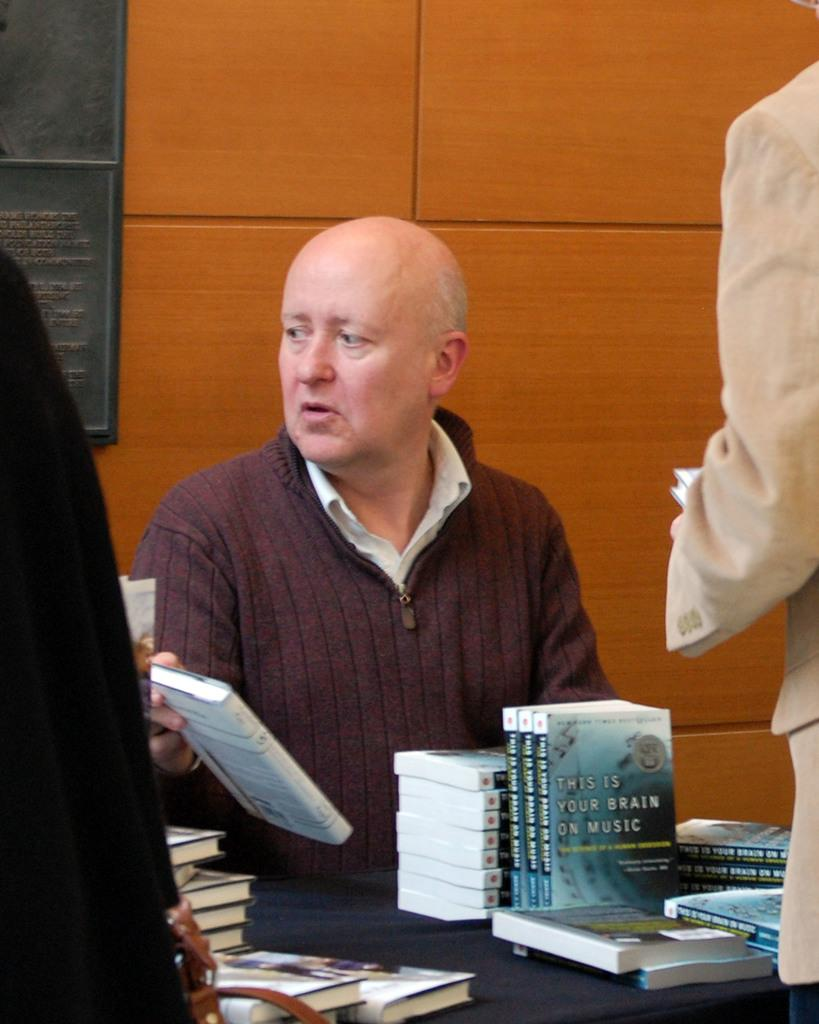<image>
Provide a brief description of the given image. An older man sits at a table with multiple copies of the book "This Is Your Brain on Music". 